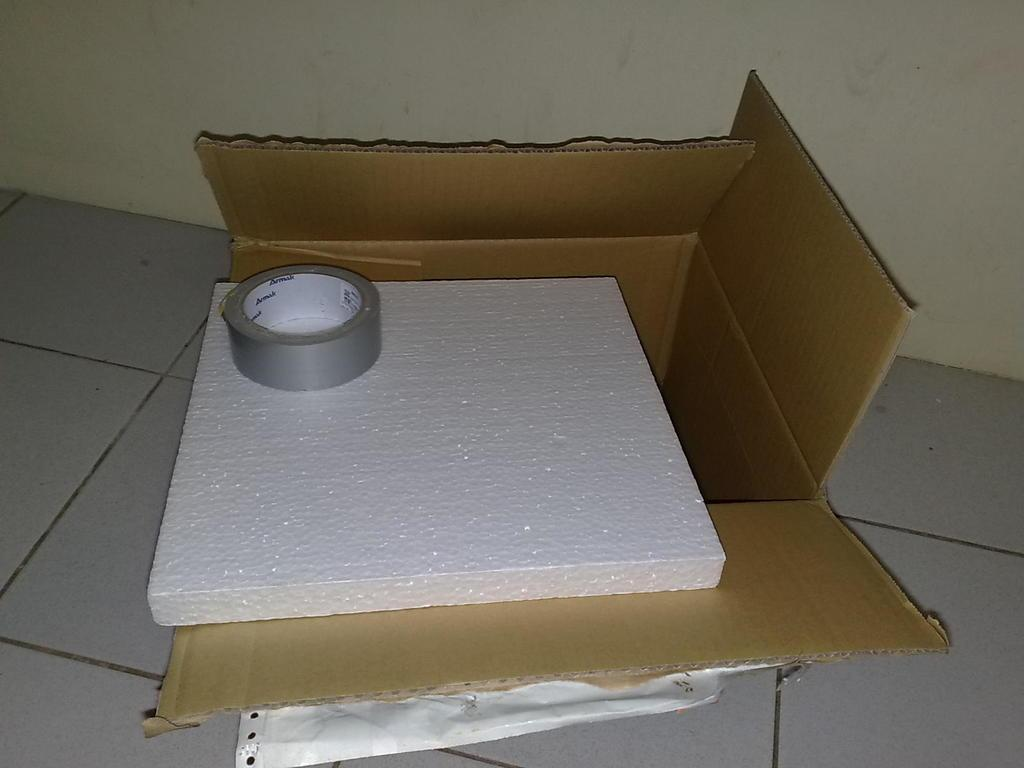What object is made of cardboard in the image? There is a cardboard box in the image. What material is used for insulation in the image? There is a thermocol sheet in the image. What is used to cover or protect something in the image? There is a cover in the image. What is used to hold or attach items together in the image? There is tape in the image. What can be seen in the background of the image? There is a wall in the background of the image. How much money is being discussed in the image? There is no mention of money or any discussion in the image; it features a cardboard box, thermocol sheet, cover, tape, and a wall in the background. 